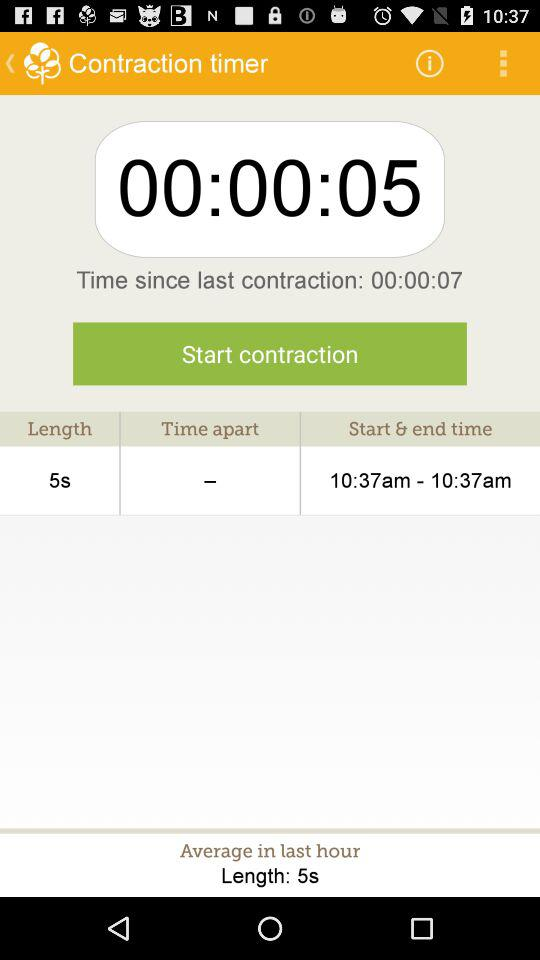What is the length (in seconds) of the "Contraction timer"? The length (in seconds) of the "Contraction timer" is 5 seconds. 